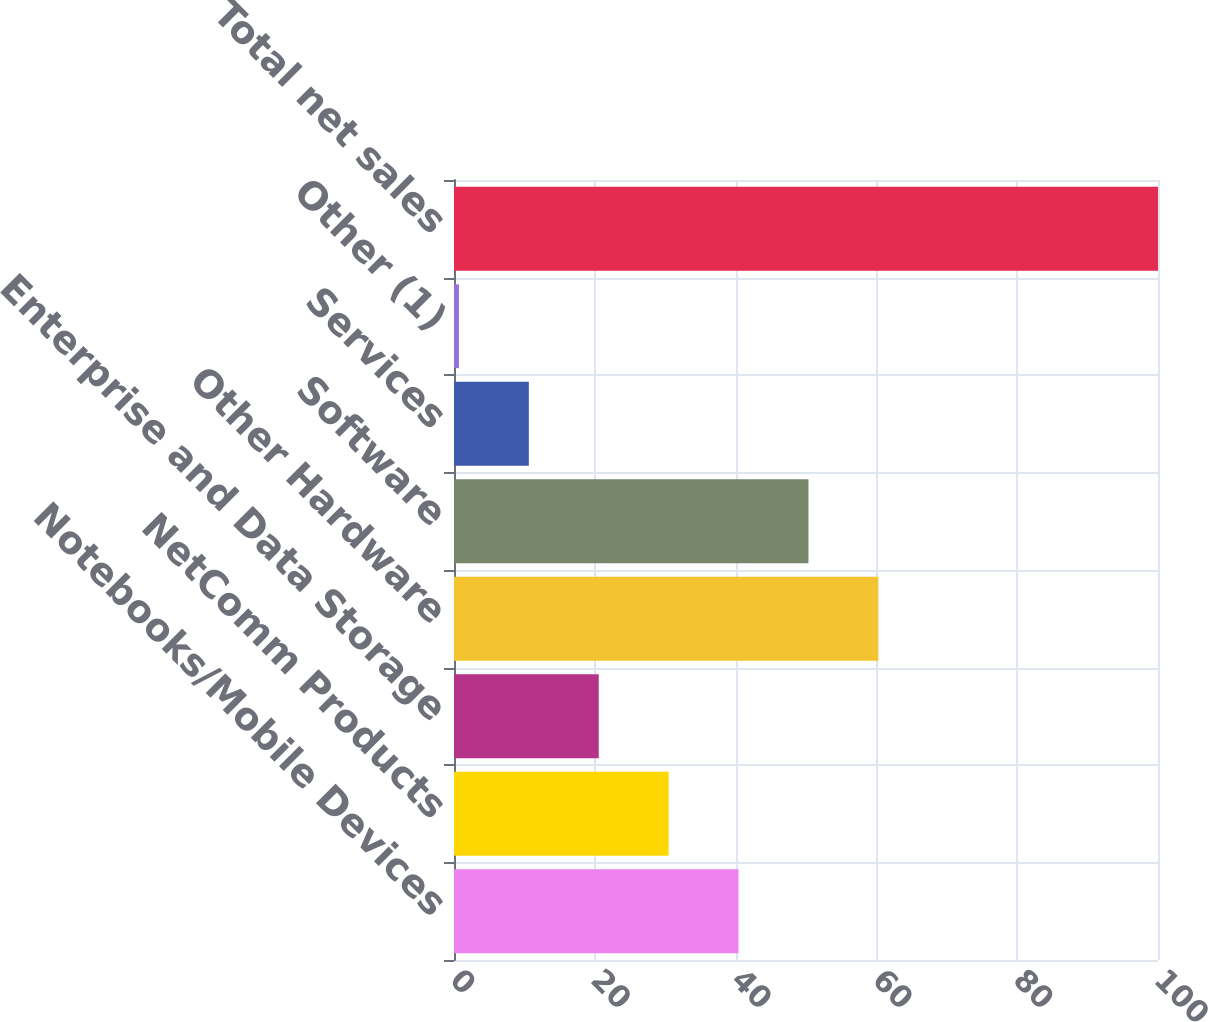Convert chart to OTSL. <chart><loc_0><loc_0><loc_500><loc_500><bar_chart><fcel>Notebooks/Mobile Devices<fcel>NetComm Products<fcel>Enterprise and Data Storage<fcel>Other Hardware<fcel>Software<fcel>Services<fcel>Other (1)<fcel>Total net sales<nl><fcel>40.42<fcel>30.49<fcel>20.56<fcel>60.28<fcel>50.35<fcel>10.63<fcel>0.7<fcel>100<nl></chart> 